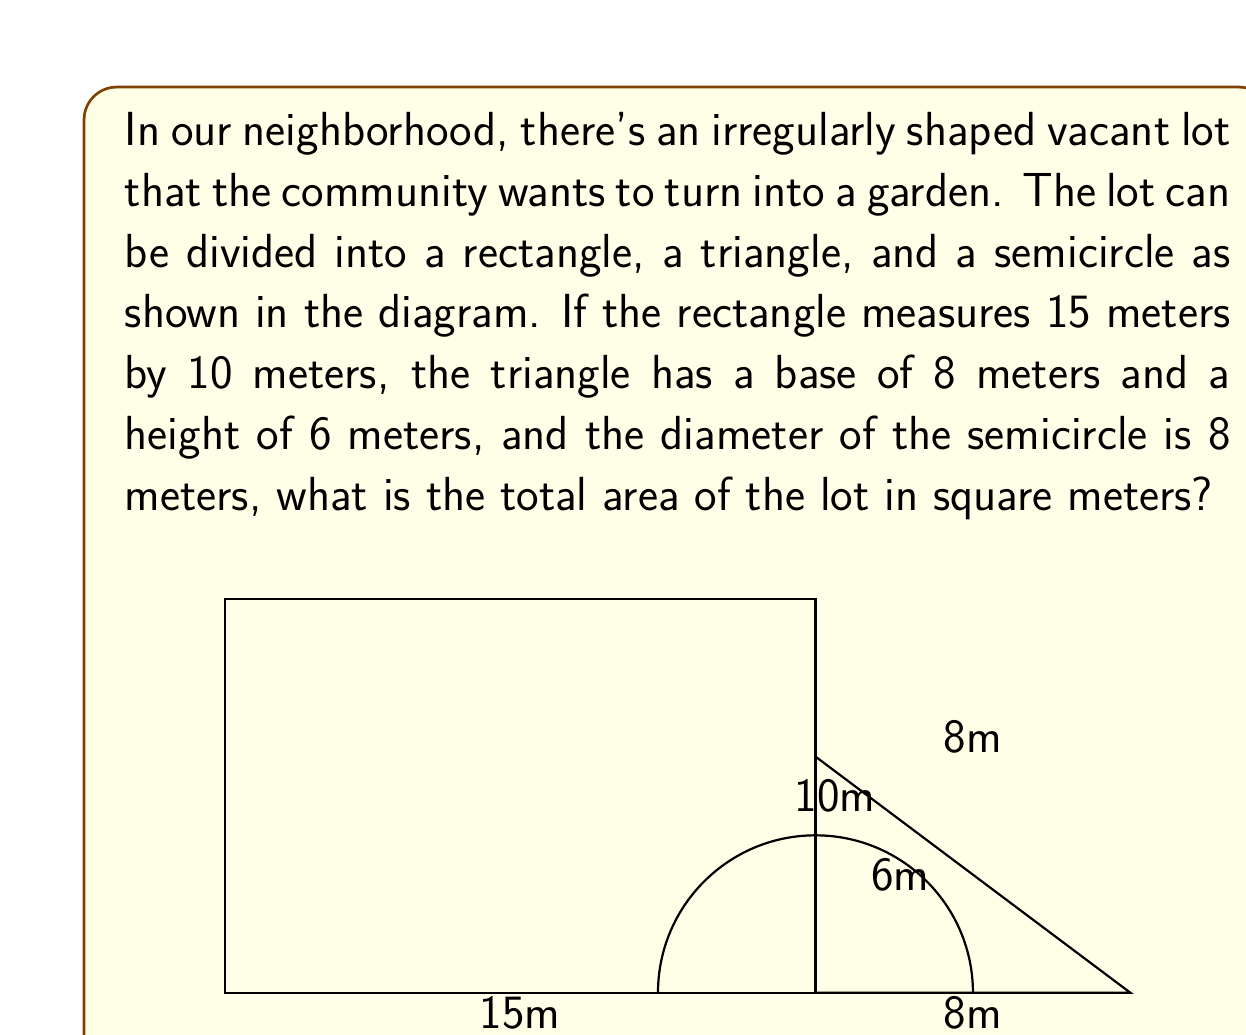Can you solve this math problem? Let's break this down step-by-step:

1) First, we need to calculate the area of each shape separately.

2) For the rectangle:
   Area of rectangle = length × width
   $A_r = 15 \text{ m} \times 10 \text{ m} = 150 \text{ m}^2$

3) For the triangle:
   Area of triangle = $\frac{1}{2} \times$ base × height
   $A_t = \frac{1}{2} \times 8 \text{ m} \times 6 \text{ m} = 24 \text{ m}^2$

4) For the semicircle:
   Area of semicircle = $\frac{1}{2} \times \pi r^2$
   The radius is half the diameter, so $r = 4 \text{ m}$
   $A_s = \frac{1}{2} \times \pi \times (4 \text{ m})^2 = 8\pi \text{ m}^2$

5) Now, we sum up all these areas:
   Total Area = $A_r + A_t + A_s$
   $= 150 \text{ m}^2 + 24 \text{ m}^2 + 8\pi \text{ m}^2$
   $= 174 + 8\pi \text{ m}^2$

6) To get a numerical value, we can use $\pi \approx 3.14159$:
   Total Area $\approx 174 + 8(3.14159) \text{ m}^2$
   $\approx 174 + 25.13272 \text{ m}^2$
   $\approx 199.13272 \text{ m}^2$

7) Rounding to two decimal places:
   Total Area $\approx 199.13 \text{ m}^2$
Answer: $199.13 \text{ m}^2$ 